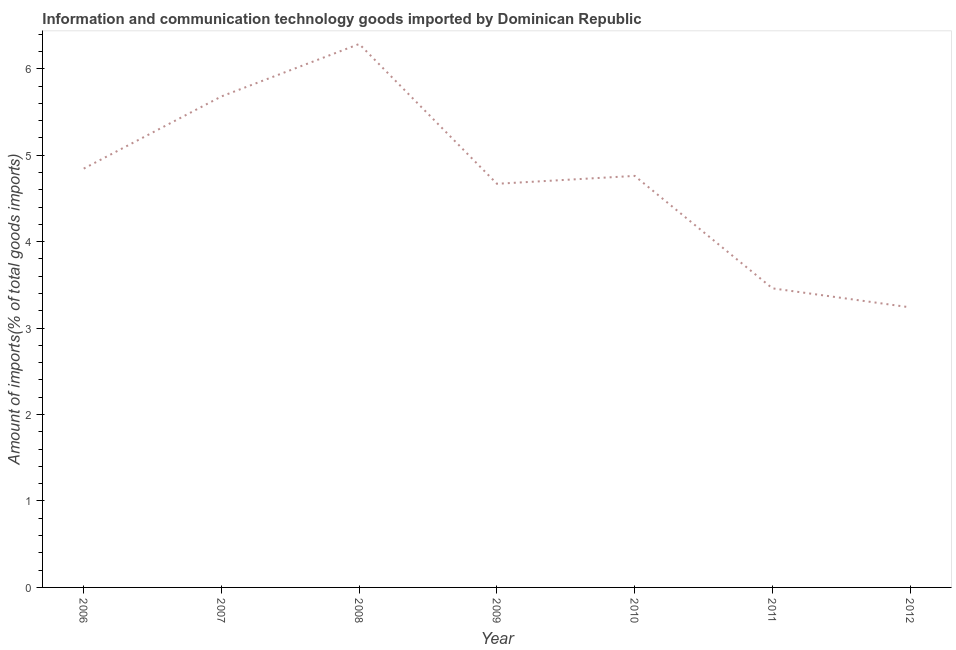What is the amount of ict goods imports in 2011?
Offer a very short reply. 3.46. Across all years, what is the maximum amount of ict goods imports?
Make the answer very short. 6.29. Across all years, what is the minimum amount of ict goods imports?
Your answer should be very brief. 3.24. In which year was the amount of ict goods imports maximum?
Make the answer very short. 2008. What is the sum of the amount of ict goods imports?
Offer a very short reply. 32.95. What is the difference between the amount of ict goods imports in 2007 and 2011?
Make the answer very short. 2.22. What is the average amount of ict goods imports per year?
Keep it short and to the point. 4.71. What is the median amount of ict goods imports?
Offer a terse response. 4.76. What is the ratio of the amount of ict goods imports in 2006 to that in 2008?
Your response must be concise. 0.77. Is the difference between the amount of ict goods imports in 2006 and 2011 greater than the difference between any two years?
Your response must be concise. No. What is the difference between the highest and the second highest amount of ict goods imports?
Make the answer very short. 0.61. What is the difference between the highest and the lowest amount of ict goods imports?
Give a very brief answer. 3.05. In how many years, is the amount of ict goods imports greater than the average amount of ict goods imports taken over all years?
Offer a very short reply. 4. How many years are there in the graph?
Provide a succinct answer. 7. What is the difference between two consecutive major ticks on the Y-axis?
Provide a short and direct response. 1. Does the graph contain grids?
Offer a very short reply. No. What is the title of the graph?
Your response must be concise. Information and communication technology goods imported by Dominican Republic. What is the label or title of the Y-axis?
Offer a very short reply. Amount of imports(% of total goods imports). What is the Amount of imports(% of total goods imports) in 2006?
Offer a very short reply. 4.85. What is the Amount of imports(% of total goods imports) of 2007?
Provide a short and direct response. 5.68. What is the Amount of imports(% of total goods imports) of 2008?
Make the answer very short. 6.29. What is the Amount of imports(% of total goods imports) of 2009?
Offer a terse response. 4.67. What is the Amount of imports(% of total goods imports) in 2010?
Your answer should be compact. 4.76. What is the Amount of imports(% of total goods imports) of 2011?
Provide a short and direct response. 3.46. What is the Amount of imports(% of total goods imports) in 2012?
Offer a very short reply. 3.24. What is the difference between the Amount of imports(% of total goods imports) in 2006 and 2007?
Provide a succinct answer. -0.84. What is the difference between the Amount of imports(% of total goods imports) in 2006 and 2008?
Offer a terse response. -1.44. What is the difference between the Amount of imports(% of total goods imports) in 2006 and 2009?
Your answer should be very brief. 0.18. What is the difference between the Amount of imports(% of total goods imports) in 2006 and 2010?
Your response must be concise. 0.08. What is the difference between the Amount of imports(% of total goods imports) in 2006 and 2011?
Your response must be concise. 1.39. What is the difference between the Amount of imports(% of total goods imports) in 2006 and 2012?
Your answer should be very brief. 1.61. What is the difference between the Amount of imports(% of total goods imports) in 2007 and 2008?
Your answer should be compact. -0.61. What is the difference between the Amount of imports(% of total goods imports) in 2007 and 2009?
Keep it short and to the point. 1.01. What is the difference between the Amount of imports(% of total goods imports) in 2007 and 2010?
Keep it short and to the point. 0.92. What is the difference between the Amount of imports(% of total goods imports) in 2007 and 2011?
Give a very brief answer. 2.22. What is the difference between the Amount of imports(% of total goods imports) in 2007 and 2012?
Your response must be concise. 2.44. What is the difference between the Amount of imports(% of total goods imports) in 2008 and 2009?
Your answer should be compact. 1.62. What is the difference between the Amount of imports(% of total goods imports) in 2008 and 2010?
Your answer should be very brief. 1.53. What is the difference between the Amount of imports(% of total goods imports) in 2008 and 2011?
Provide a succinct answer. 2.83. What is the difference between the Amount of imports(% of total goods imports) in 2008 and 2012?
Provide a succinct answer. 3.05. What is the difference between the Amount of imports(% of total goods imports) in 2009 and 2010?
Provide a succinct answer. -0.09. What is the difference between the Amount of imports(% of total goods imports) in 2009 and 2011?
Your response must be concise. 1.21. What is the difference between the Amount of imports(% of total goods imports) in 2009 and 2012?
Ensure brevity in your answer.  1.43. What is the difference between the Amount of imports(% of total goods imports) in 2010 and 2011?
Provide a succinct answer. 1.3. What is the difference between the Amount of imports(% of total goods imports) in 2010 and 2012?
Ensure brevity in your answer.  1.52. What is the difference between the Amount of imports(% of total goods imports) in 2011 and 2012?
Your answer should be compact. 0.22. What is the ratio of the Amount of imports(% of total goods imports) in 2006 to that in 2007?
Give a very brief answer. 0.85. What is the ratio of the Amount of imports(% of total goods imports) in 2006 to that in 2008?
Make the answer very short. 0.77. What is the ratio of the Amount of imports(% of total goods imports) in 2006 to that in 2009?
Your answer should be very brief. 1.04. What is the ratio of the Amount of imports(% of total goods imports) in 2006 to that in 2011?
Your answer should be compact. 1.4. What is the ratio of the Amount of imports(% of total goods imports) in 2006 to that in 2012?
Make the answer very short. 1.5. What is the ratio of the Amount of imports(% of total goods imports) in 2007 to that in 2008?
Provide a short and direct response. 0.9. What is the ratio of the Amount of imports(% of total goods imports) in 2007 to that in 2009?
Offer a terse response. 1.22. What is the ratio of the Amount of imports(% of total goods imports) in 2007 to that in 2010?
Offer a terse response. 1.19. What is the ratio of the Amount of imports(% of total goods imports) in 2007 to that in 2011?
Your answer should be compact. 1.64. What is the ratio of the Amount of imports(% of total goods imports) in 2007 to that in 2012?
Provide a short and direct response. 1.75. What is the ratio of the Amount of imports(% of total goods imports) in 2008 to that in 2009?
Keep it short and to the point. 1.35. What is the ratio of the Amount of imports(% of total goods imports) in 2008 to that in 2010?
Keep it short and to the point. 1.32. What is the ratio of the Amount of imports(% of total goods imports) in 2008 to that in 2011?
Your response must be concise. 1.82. What is the ratio of the Amount of imports(% of total goods imports) in 2008 to that in 2012?
Ensure brevity in your answer.  1.94. What is the ratio of the Amount of imports(% of total goods imports) in 2009 to that in 2011?
Provide a short and direct response. 1.35. What is the ratio of the Amount of imports(% of total goods imports) in 2009 to that in 2012?
Give a very brief answer. 1.44. What is the ratio of the Amount of imports(% of total goods imports) in 2010 to that in 2011?
Offer a very short reply. 1.38. What is the ratio of the Amount of imports(% of total goods imports) in 2010 to that in 2012?
Ensure brevity in your answer.  1.47. What is the ratio of the Amount of imports(% of total goods imports) in 2011 to that in 2012?
Provide a short and direct response. 1.07. 